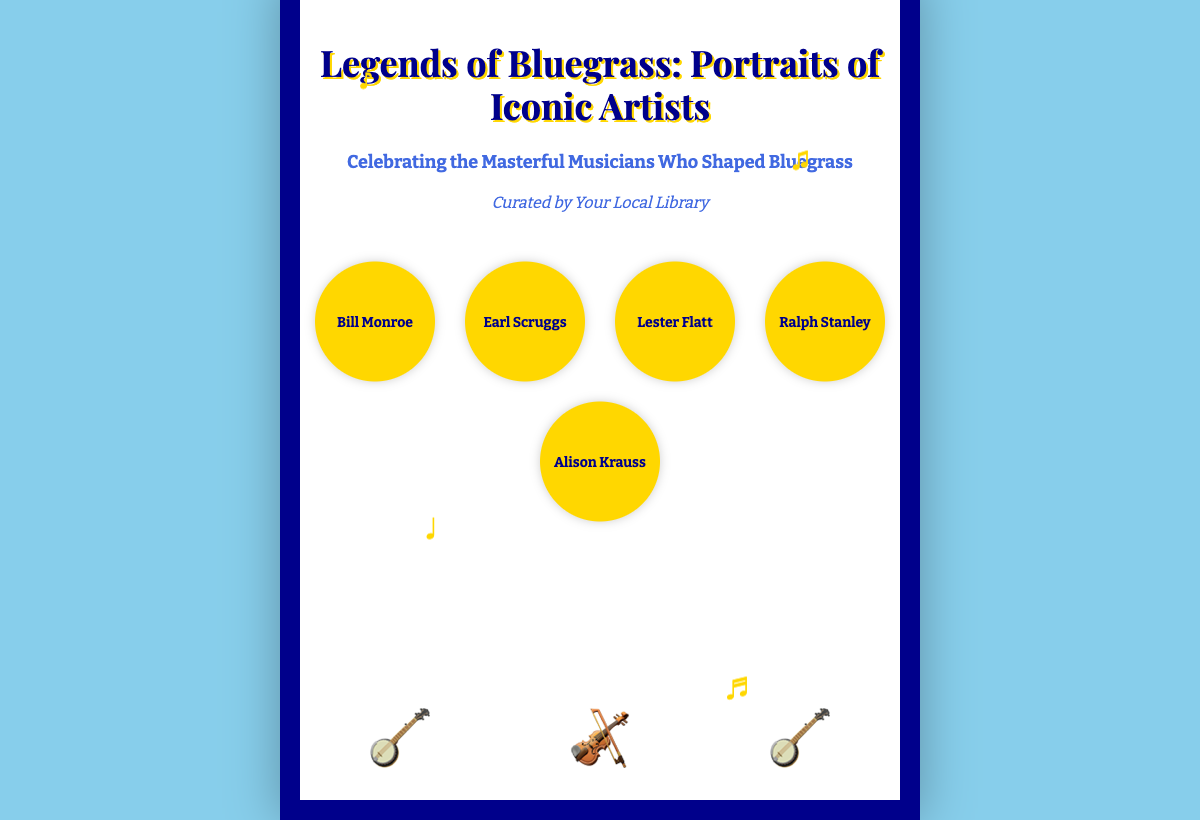What is the title of the book? The title of the book is prominently displayed at the top of the cover.
Answer: Legends of Bluegrass: Portraits of Iconic Artists Who is the author of the book? The author is mentioned at the bottom of the cover, indicating who curated the book.
Answer: Curated by Your Local Library How many portraits are displayed? The document contains five portraits of bluegrass musicians, each represented in a circular format.
Answer: Five What color is the background of the book cover? The background color of the book cover is specified in the style section of the document.
Answer: Light blue Which instrument color is represented as forest green? The document specifies different colors for the instruments; one is given as forest green.
Answer: Banjo What type of document is this? The structure and content indicate that it is formatted to present a specific type of book cover.
Answer: Book cover What is the subtitle of the book? The subtitle provides additional context about the book, located below the title.
Answer: Celebrating the Masterful Musicians Who Shaped Bluegrass Which musical note is floating at the top left? The document includes multiple musical notes with specific positions mentioned.
Answer: ♪ How many musicians are named on the cover? The names of the musicians displayed in the portraits on the cover count to a specific number.
Answer: Five 